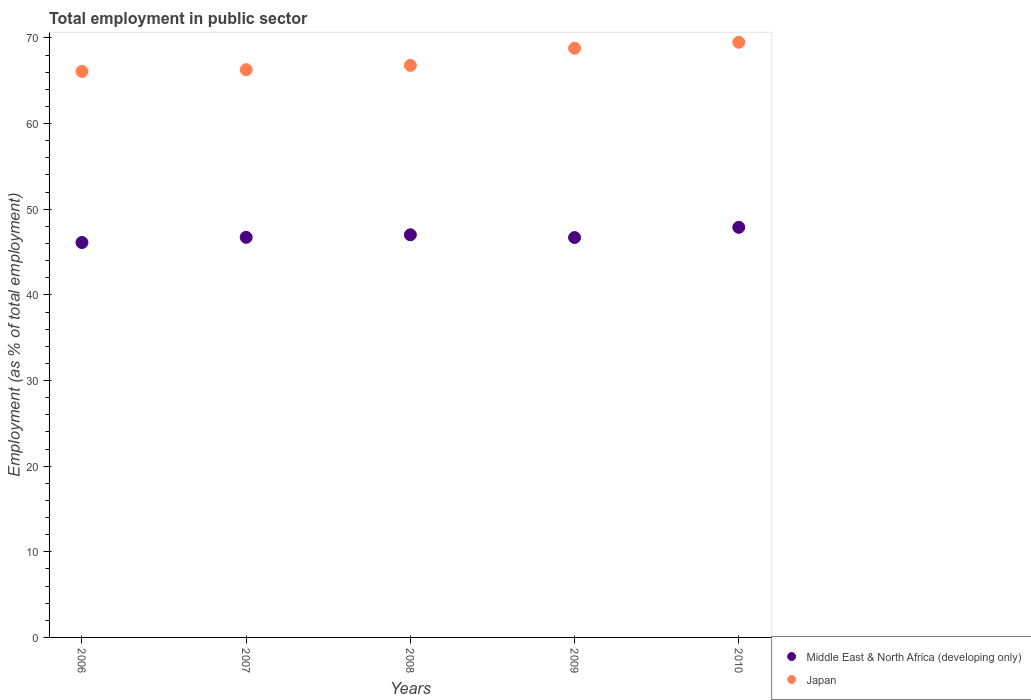Is the number of dotlines equal to the number of legend labels?
Provide a short and direct response. Yes. What is the employment in public sector in Middle East & North Africa (developing only) in 2009?
Give a very brief answer. 46.7. Across all years, what is the maximum employment in public sector in Japan?
Your answer should be compact. 69.5. Across all years, what is the minimum employment in public sector in Middle East & North Africa (developing only)?
Offer a very short reply. 46.12. What is the total employment in public sector in Middle East & North Africa (developing only) in the graph?
Ensure brevity in your answer.  234.44. What is the difference between the employment in public sector in Japan in 2006 and the employment in public sector in Middle East & North Africa (developing only) in 2008?
Give a very brief answer. 19.08. What is the average employment in public sector in Japan per year?
Offer a terse response. 67.5. In the year 2009, what is the difference between the employment in public sector in Middle East & North Africa (developing only) and employment in public sector in Japan?
Provide a short and direct response. -22.1. What is the ratio of the employment in public sector in Middle East & North Africa (developing only) in 2008 to that in 2009?
Provide a succinct answer. 1.01. Is the employment in public sector in Japan in 2007 less than that in 2008?
Ensure brevity in your answer.  Yes. Is the difference between the employment in public sector in Middle East & North Africa (developing only) in 2008 and 2009 greater than the difference between the employment in public sector in Japan in 2008 and 2009?
Provide a short and direct response. Yes. What is the difference between the highest and the second highest employment in public sector in Middle East & North Africa (developing only)?
Offer a terse response. 0.87. What is the difference between the highest and the lowest employment in public sector in Middle East & North Africa (developing only)?
Your response must be concise. 1.77. Is the sum of the employment in public sector in Middle East & North Africa (developing only) in 2007 and 2009 greater than the maximum employment in public sector in Japan across all years?
Make the answer very short. Yes. How many years are there in the graph?
Offer a very short reply. 5. Does the graph contain any zero values?
Offer a very short reply. No. Does the graph contain grids?
Offer a very short reply. No. Where does the legend appear in the graph?
Offer a very short reply. Bottom right. How are the legend labels stacked?
Ensure brevity in your answer.  Vertical. What is the title of the graph?
Provide a short and direct response. Total employment in public sector. What is the label or title of the Y-axis?
Keep it short and to the point. Employment (as % of total employment). What is the Employment (as % of total employment) in Middle East & North Africa (developing only) in 2006?
Keep it short and to the point. 46.12. What is the Employment (as % of total employment) in Japan in 2006?
Your answer should be very brief. 66.1. What is the Employment (as % of total employment) in Middle East & North Africa (developing only) in 2007?
Provide a succinct answer. 46.72. What is the Employment (as % of total employment) in Japan in 2007?
Provide a short and direct response. 66.3. What is the Employment (as % of total employment) of Middle East & North Africa (developing only) in 2008?
Offer a terse response. 47.02. What is the Employment (as % of total employment) in Japan in 2008?
Make the answer very short. 66.8. What is the Employment (as % of total employment) in Middle East & North Africa (developing only) in 2009?
Provide a short and direct response. 46.7. What is the Employment (as % of total employment) in Japan in 2009?
Make the answer very short. 68.8. What is the Employment (as % of total employment) in Middle East & North Africa (developing only) in 2010?
Give a very brief answer. 47.89. What is the Employment (as % of total employment) in Japan in 2010?
Your answer should be very brief. 69.5. Across all years, what is the maximum Employment (as % of total employment) in Middle East & North Africa (developing only)?
Provide a succinct answer. 47.89. Across all years, what is the maximum Employment (as % of total employment) of Japan?
Offer a very short reply. 69.5. Across all years, what is the minimum Employment (as % of total employment) in Middle East & North Africa (developing only)?
Ensure brevity in your answer.  46.12. Across all years, what is the minimum Employment (as % of total employment) of Japan?
Your answer should be compact. 66.1. What is the total Employment (as % of total employment) in Middle East & North Africa (developing only) in the graph?
Keep it short and to the point. 234.44. What is the total Employment (as % of total employment) of Japan in the graph?
Make the answer very short. 337.5. What is the difference between the Employment (as % of total employment) in Middle East & North Africa (developing only) in 2006 and that in 2007?
Your answer should be compact. -0.61. What is the difference between the Employment (as % of total employment) in Japan in 2006 and that in 2007?
Give a very brief answer. -0.2. What is the difference between the Employment (as % of total employment) in Middle East & North Africa (developing only) in 2006 and that in 2008?
Make the answer very short. -0.9. What is the difference between the Employment (as % of total employment) in Japan in 2006 and that in 2008?
Make the answer very short. -0.7. What is the difference between the Employment (as % of total employment) of Middle East & North Africa (developing only) in 2006 and that in 2009?
Your answer should be very brief. -0.58. What is the difference between the Employment (as % of total employment) in Middle East & North Africa (developing only) in 2006 and that in 2010?
Make the answer very short. -1.77. What is the difference between the Employment (as % of total employment) of Middle East & North Africa (developing only) in 2007 and that in 2008?
Offer a terse response. -0.3. What is the difference between the Employment (as % of total employment) in Japan in 2007 and that in 2008?
Ensure brevity in your answer.  -0.5. What is the difference between the Employment (as % of total employment) in Middle East & North Africa (developing only) in 2007 and that in 2009?
Your answer should be very brief. 0.03. What is the difference between the Employment (as % of total employment) of Middle East & North Africa (developing only) in 2007 and that in 2010?
Your response must be concise. -1.17. What is the difference between the Employment (as % of total employment) of Middle East & North Africa (developing only) in 2008 and that in 2009?
Keep it short and to the point. 0.32. What is the difference between the Employment (as % of total employment) of Japan in 2008 and that in 2009?
Your response must be concise. -2. What is the difference between the Employment (as % of total employment) of Middle East & North Africa (developing only) in 2008 and that in 2010?
Offer a very short reply. -0.87. What is the difference between the Employment (as % of total employment) of Middle East & North Africa (developing only) in 2009 and that in 2010?
Your response must be concise. -1.19. What is the difference between the Employment (as % of total employment) in Middle East & North Africa (developing only) in 2006 and the Employment (as % of total employment) in Japan in 2007?
Give a very brief answer. -20.18. What is the difference between the Employment (as % of total employment) of Middle East & North Africa (developing only) in 2006 and the Employment (as % of total employment) of Japan in 2008?
Your response must be concise. -20.68. What is the difference between the Employment (as % of total employment) in Middle East & North Africa (developing only) in 2006 and the Employment (as % of total employment) in Japan in 2009?
Make the answer very short. -22.68. What is the difference between the Employment (as % of total employment) of Middle East & North Africa (developing only) in 2006 and the Employment (as % of total employment) of Japan in 2010?
Provide a short and direct response. -23.38. What is the difference between the Employment (as % of total employment) in Middle East & North Africa (developing only) in 2007 and the Employment (as % of total employment) in Japan in 2008?
Provide a short and direct response. -20.08. What is the difference between the Employment (as % of total employment) of Middle East & North Africa (developing only) in 2007 and the Employment (as % of total employment) of Japan in 2009?
Give a very brief answer. -22.08. What is the difference between the Employment (as % of total employment) in Middle East & North Africa (developing only) in 2007 and the Employment (as % of total employment) in Japan in 2010?
Your response must be concise. -22.78. What is the difference between the Employment (as % of total employment) of Middle East & North Africa (developing only) in 2008 and the Employment (as % of total employment) of Japan in 2009?
Your answer should be compact. -21.78. What is the difference between the Employment (as % of total employment) of Middle East & North Africa (developing only) in 2008 and the Employment (as % of total employment) of Japan in 2010?
Give a very brief answer. -22.48. What is the difference between the Employment (as % of total employment) in Middle East & North Africa (developing only) in 2009 and the Employment (as % of total employment) in Japan in 2010?
Offer a terse response. -22.8. What is the average Employment (as % of total employment) in Middle East & North Africa (developing only) per year?
Ensure brevity in your answer.  46.89. What is the average Employment (as % of total employment) in Japan per year?
Provide a short and direct response. 67.5. In the year 2006, what is the difference between the Employment (as % of total employment) in Middle East & North Africa (developing only) and Employment (as % of total employment) in Japan?
Your answer should be compact. -19.98. In the year 2007, what is the difference between the Employment (as % of total employment) of Middle East & North Africa (developing only) and Employment (as % of total employment) of Japan?
Your answer should be very brief. -19.58. In the year 2008, what is the difference between the Employment (as % of total employment) of Middle East & North Africa (developing only) and Employment (as % of total employment) of Japan?
Make the answer very short. -19.78. In the year 2009, what is the difference between the Employment (as % of total employment) of Middle East & North Africa (developing only) and Employment (as % of total employment) of Japan?
Your response must be concise. -22.1. In the year 2010, what is the difference between the Employment (as % of total employment) in Middle East & North Africa (developing only) and Employment (as % of total employment) in Japan?
Offer a very short reply. -21.61. What is the ratio of the Employment (as % of total employment) of Japan in 2006 to that in 2007?
Your answer should be very brief. 1. What is the ratio of the Employment (as % of total employment) in Middle East & North Africa (developing only) in 2006 to that in 2008?
Make the answer very short. 0.98. What is the ratio of the Employment (as % of total employment) in Japan in 2006 to that in 2008?
Ensure brevity in your answer.  0.99. What is the ratio of the Employment (as % of total employment) of Middle East & North Africa (developing only) in 2006 to that in 2009?
Keep it short and to the point. 0.99. What is the ratio of the Employment (as % of total employment) in Japan in 2006 to that in 2009?
Your answer should be compact. 0.96. What is the ratio of the Employment (as % of total employment) in Japan in 2006 to that in 2010?
Offer a very short reply. 0.95. What is the ratio of the Employment (as % of total employment) of Middle East & North Africa (developing only) in 2007 to that in 2008?
Your response must be concise. 0.99. What is the ratio of the Employment (as % of total employment) of Japan in 2007 to that in 2008?
Offer a very short reply. 0.99. What is the ratio of the Employment (as % of total employment) of Japan in 2007 to that in 2009?
Make the answer very short. 0.96. What is the ratio of the Employment (as % of total employment) in Middle East & North Africa (developing only) in 2007 to that in 2010?
Offer a very short reply. 0.98. What is the ratio of the Employment (as % of total employment) in Japan in 2007 to that in 2010?
Ensure brevity in your answer.  0.95. What is the ratio of the Employment (as % of total employment) of Middle East & North Africa (developing only) in 2008 to that in 2009?
Ensure brevity in your answer.  1.01. What is the ratio of the Employment (as % of total employment) in Japan in 2008 to that in 2009?
Offer a very short reply. 0.97. What is the ratio of the Employment (as % of total employment) of Middle East & North Africa (developing only) in 2008 to that in 2010?
Offer a very short reply. 0.98. What is the ratio of the Employment (as % of total employment) in Japan in 2008 to that in 2010?
Ensure brevity in your answer.  0.96. What is the ratio of the Employment (as % of total employment) of Middle East & North Africa (developing only) in 2009 to that in 2010?
Ensure brevity in your answer.  0.98. What is the ratio of the Employment (as % of total employment) of Japan in 2009 to that in 2010?
Your answer should be compact. 0.99. What is the difference between the highest and the second highest Employment (as % of total employment) of Middle East & North Africa (developing only)?
Give a very brief answer. 0.87. What is the difference between the highest and the second highest Employment (as % of total employment) of Japan?
Offer a very short reply. 0.7. What is the difference between the highest and the lowest Employment (as % of total employment) of Middle East & North Africa (developing only)?
Your answer should be compact. 1.77. 